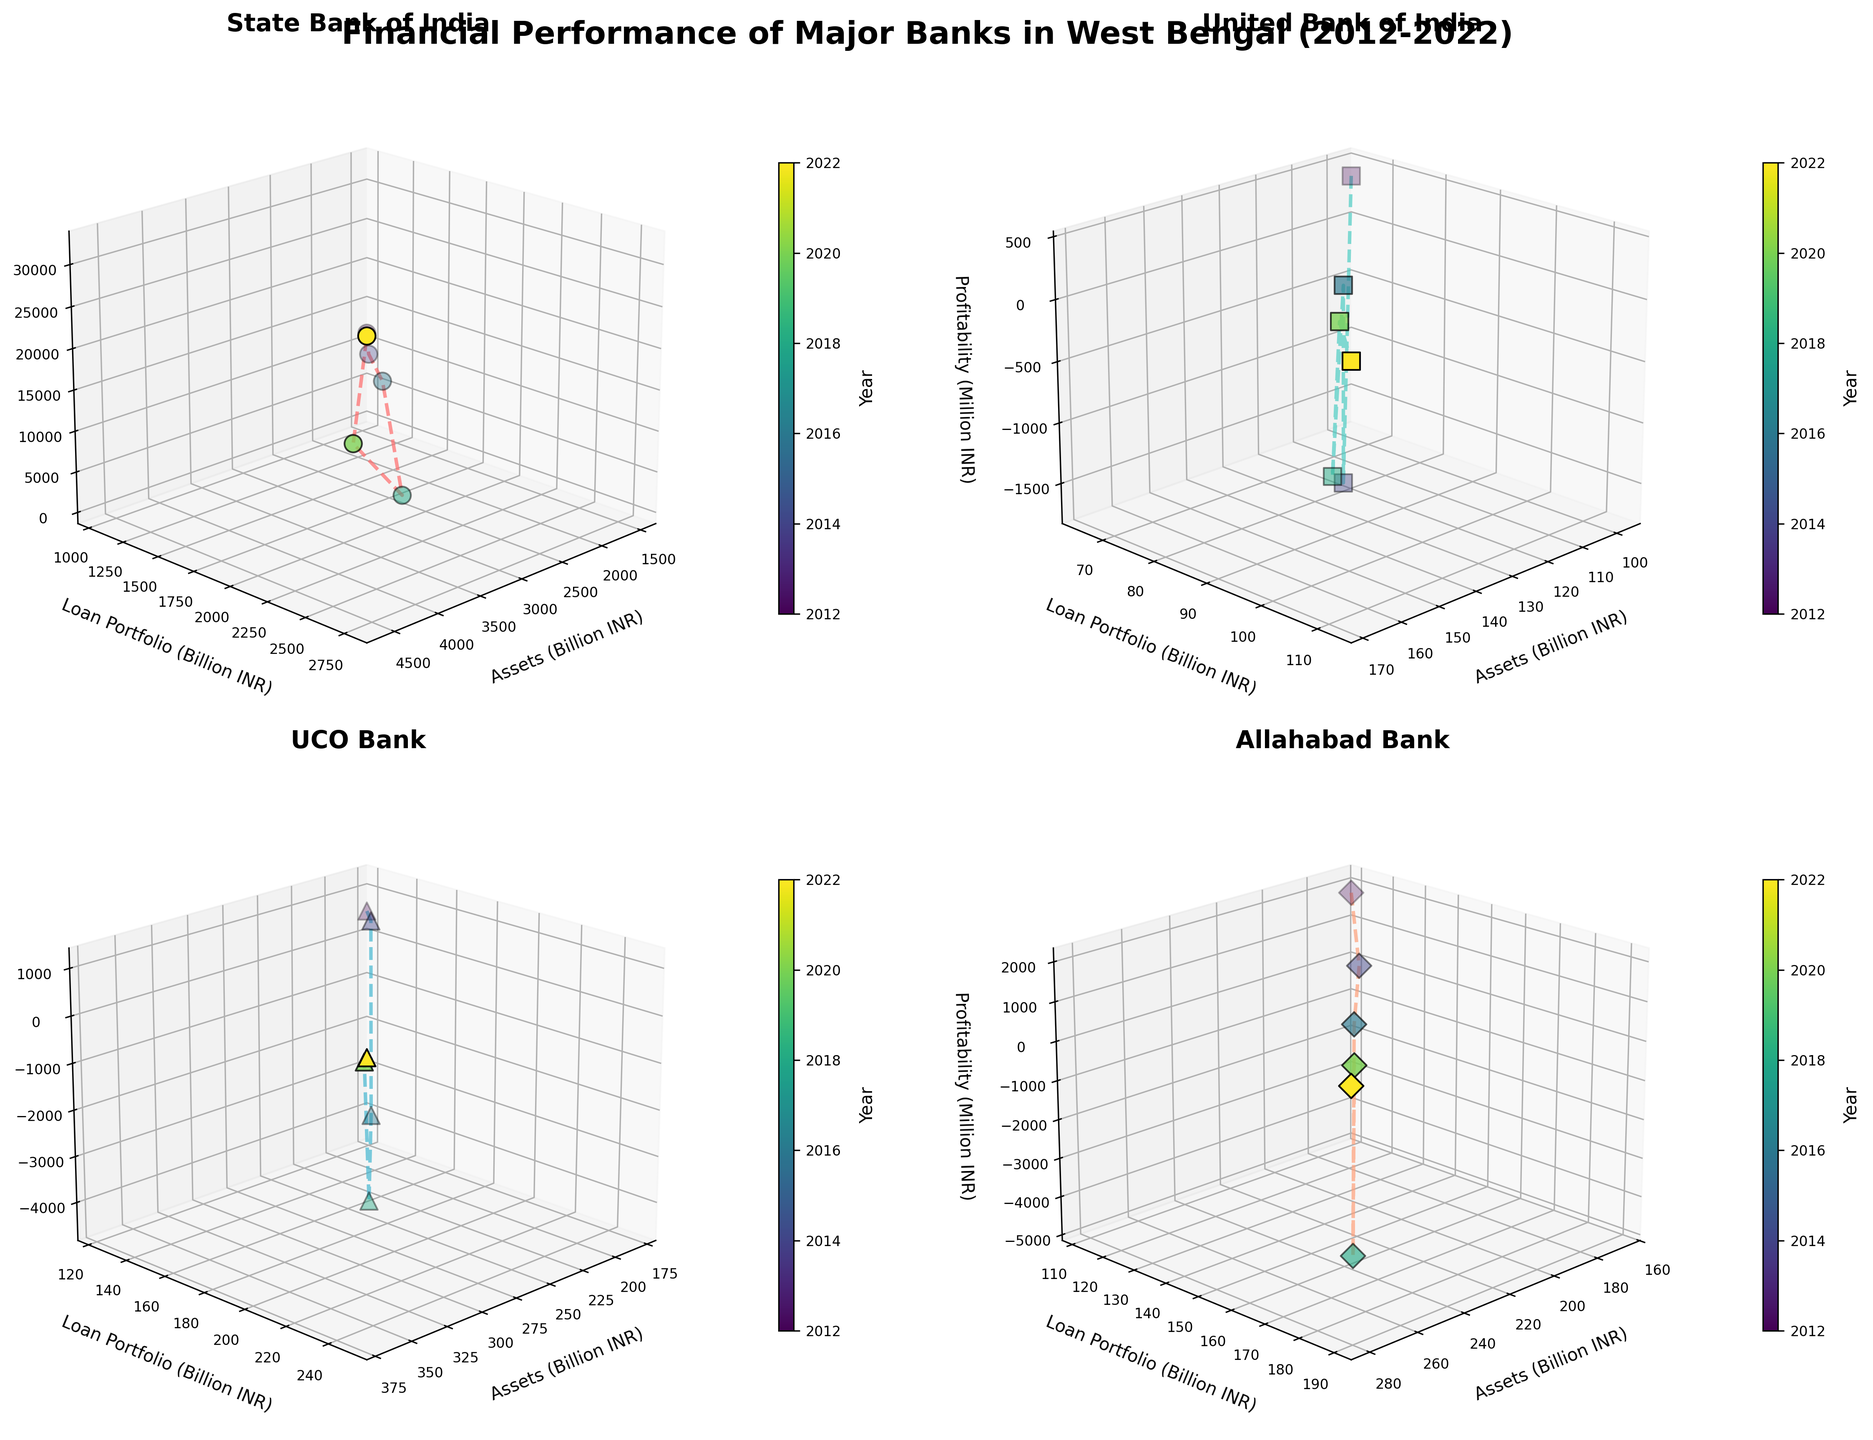What is the title of the figure? The title is located at the top of the figure and summarizes the key content, "Financial Performance of Major Banks in West Bengal (2012-2022)". This provides a quick overview of what to expect from the visual representation.
Answer: Financial Performance of Major Banks in West Bengal (2012-2022) Which bank shows the highest profitability in 2022? To find the highest profitability in 2022, one needs to look at the z-axis (Profitability) and focus on the data points marked for the year 2022. The State Bank of India has the highest profitability data point among all, noted by the color map and marker height.
Answer: State Bank of India Between 2012 and 2022, which bank had the most significant growth in assets? Compare the x-axis (Assets) values for 2012 and 2022 for each bank's subplot. The State Bank of India shows the most significant growth, increasing from around 1523.45 billion INR in 2012 to 4589.23 billion INR in 2022.
Answer: State Bank of India Which bank had a negative profitability in the year 2016? Locate the 2016 data points on the z-axis (Profitability) for each subplot. The UCO Bank had a negative profitability in 2016, as indicated by its negative z-axis value for that year.
Answer: UCO Bank Did State Bank of India show a trend of increasing profitability over the years? Examine the Z-axis for the State Bank of India's subplot from 2012 to 2022. The profitability increased from 2012 to 2014 and subsequently varied but ending much higher in 2022 compared to other years.
Answer: Yes How does the loan portfolio in 2022 compare between Allahabad Bank and UCO Bank? Check the y-axis (Loan Portfolio) values for 2022 in the respective subplots for both banks. Allahabad Bank has a value around 189.23 billion INR, while UCO Bank has approximately 248.67 billion INR.
Answer: UCO Bank has a higher loan portfolio Which bank recorded the lowest profitability in 2018? Locate the 2018 data points on the z-axis for each bank's subplot. Allahabad Bank has the lowest profitability with a noticeable negative value in 2018.
Answer: Allahabad Bank Has UCO Bank's loan portfolio consistently increased over the years? Examine the y-axis values (Loan Portfolio) across different years in the subplot of UCO Bank from 2012 to 2022. This shows an overall increasing trend in the loan portfolio.
Answer: Yes In which year did United Bank of India record a profitability above zero after 2012? Check the z-axis values (Profitability) for United Bank of India's subplot from 2012 onwards. In the year 2020, United Bank of India recorded a positive profitability.
Answer: 2020 What is the color associated with the year 2022 in the figure? To determine the color representation for 2022, refer to the colorbar in the figure, which maps years to specific colors. The color towards the end of the spectrum, often a bright color, should represent 2022.
Answer: Bright color near the end of the spectrum 